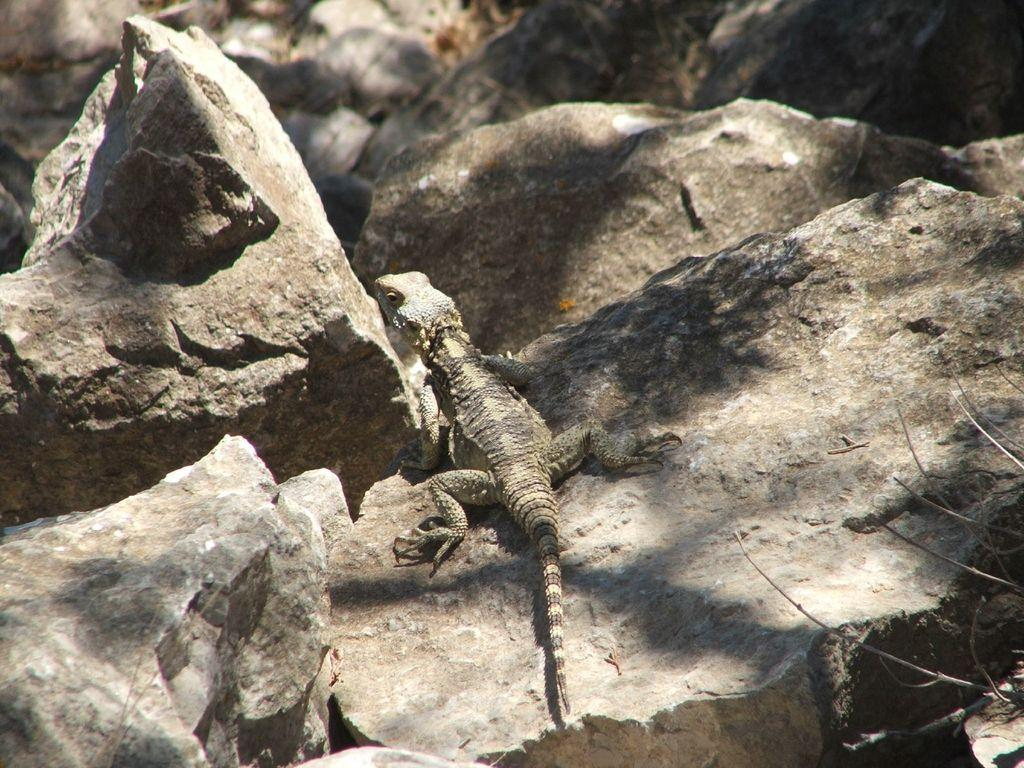What is the main subject in the center of the image? There is a lizard in the center of the image. What can be seen in the background of the image? There are rocks and twigs visible in the background of the image. What type of event is taking place in the image? There is no event taking place in the image; it is a still image of a lizard and its surroundings. Can you tell me how much water is present in the image? There is no water visible in the image; it features a lizard and its surroundings, which include rocks and twigs. 